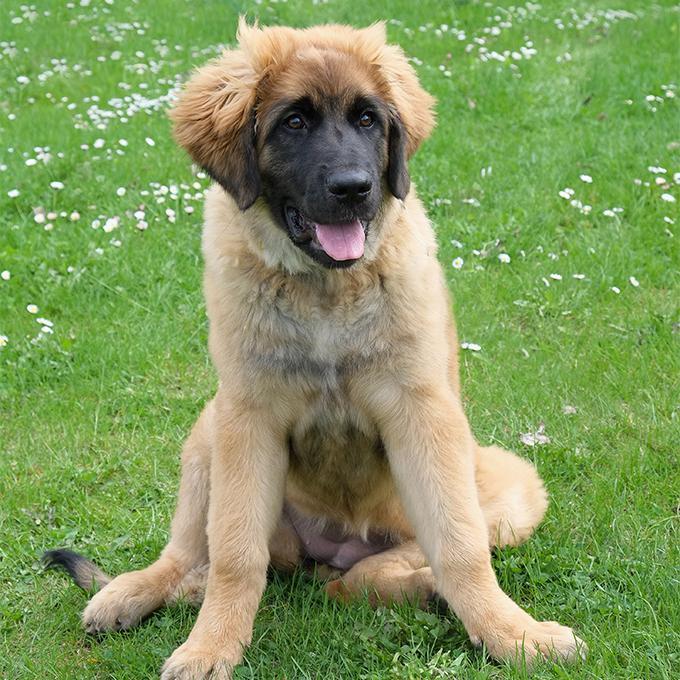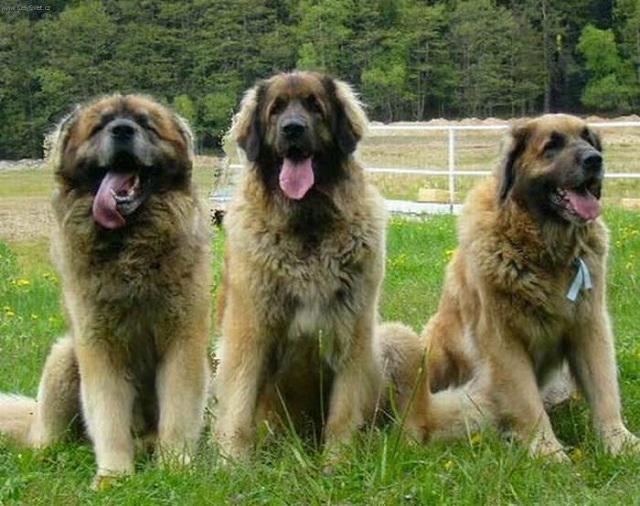The first image is the image on the left, the second image is the image on the right. Given the left and right images, does the statement "Right image contains more dogs than the left image." hold true? Answer yes or no. Yes. The first image is the image on the left, the second image is the image on the right. For the images displayed, is the sentence "One dog is sitting in the short grass in the image on the left." factually correct? Answer yes or no. Yes. 